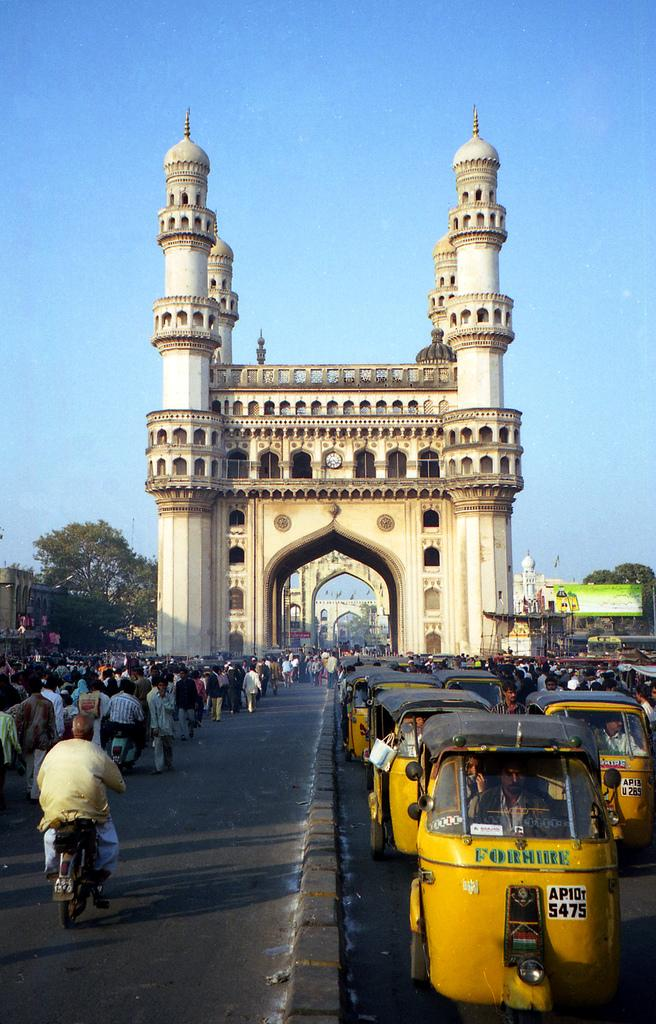<image>
Create a compact narrative representing the image presented. As people on bikes are headed towards a tall, palace looking bridge, small, yellow vehicles that say Forhire are pointed in the opposite direction. 